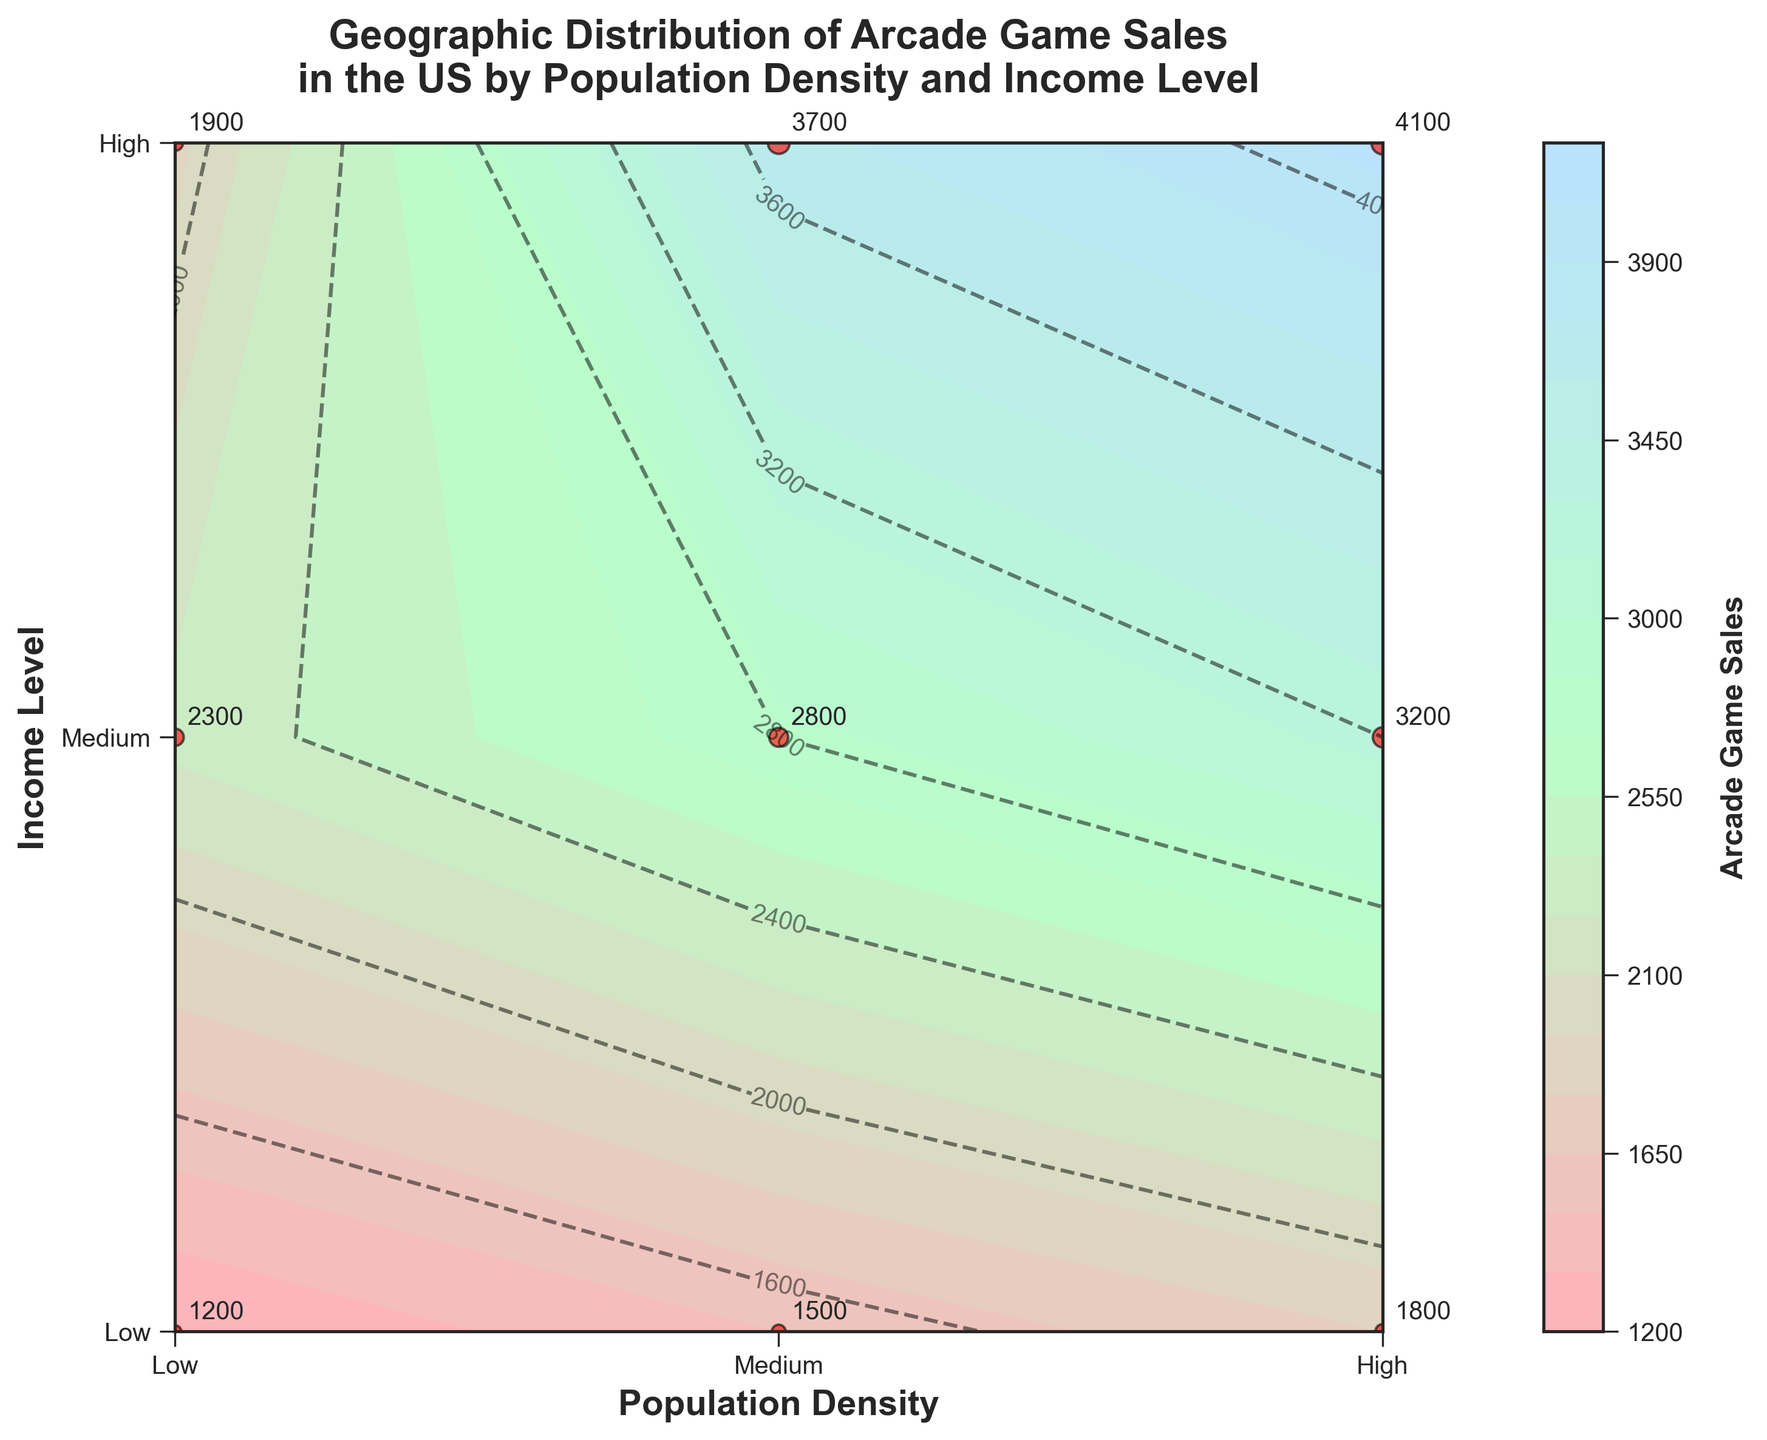What is the title of the figure? The title is typically located at the top of the figure. The title reads "Geographic Distribution of Arcade Game Sales in the US by Population Density and Income Level".
Answer: Geographic Distribution of Arcade Game Sales in the US by Population Density and Income Level What are the x-axis and y-axis labels in the figure? The x-axis and y-axis labels are found along the horizontal and vertical axes, respectively. The x-axis is labeled "Population Density", and the y-axis is labeled "Income Level".
Answer: x-axis: Population Density, y-axis: Income Level How many unique data points are plotted in the figure? Each red point in the plot, marked by a scatter, represents a unique data point. There are 9 red points in total, each labeled with its corresponding arcade game sales value.
Answer: 9 Which region shows the highest arcade game sales? The highest value is indicated by the highest contour levels and the largest scatter point, found where both Population Density and Income Level are "High". The value is 4100.
Answer: High Population Density, High Income Level What is the color gradient used for the contour levels? The contour levels use a gradient from light pink to light green to light blue, indicating increasing arcade game sales. This color variation helps to differentiate between sales levels visually.
Answer: Pink to Green to Blue What is the average arcade game sales for Medium Income Level across all population densities? To find the average, sum the arcade game sales for Medium Income (2300 + 2800 + 3200) and divide by 3. The calculation is (2300 + 2800 + 3200) / 3 = 2766.67.
Answer: 2766.67 Compare arcade game sales between Low Population Density and High Population Density for Low Income Level. The sales for Low Income and Low Density are 1200 and for Low Income and High Density are 1800. Clearly, 1800 (High Density) is more than 1200 (Low Density).
Answer: 1800 > 1200 What contour levels intersect at (Medium, Medium)? Observe the contour lines at the intersection of Medium Population Density and Medium Income Level. The labeled contour line at this intersection represents sales levels around 2800.
Answer: Around 2800 How do arcade game sales differ between Low Income and High Income for Medium Population Density? The sales for Low Income at Medium Density are 1500, and for High Income at Medium Density are 3700. The difference is calculated as 3700 - 1500 = 2200.
Answer: 2200 What income level and population density combination has the lowest arcade game sales? By observing the scatter points and labels, the lowest arcade game sales occur at the combination Low Income and Low Population Density, with a sales value of 1200.
Answer: Low Income, Low Population Density, 1200 